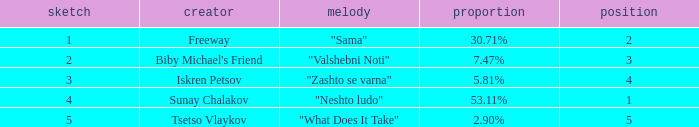Can you give me this table as a dict? {'header': ['sketch', 'creator', 'melody', 'proportion', 'position'], 'rows': [['1', 'Freeway', '"Sama"', '30.71%', '2'], ['2', "Biby Michael's Friend", '"Valshebni Noti"', '7.47%', '3'], ['3', 'Iskren Petsov', '"Zashto se varna"', '5.81%', '4'], ['4', 'Sunay Chalakov', '"Neshto ludo"', '53.11%', '1'], ['5', 'Tsetso Vlaykov', '"What Does It Take"', '2.90%', '5']]} What is the least draw when the place is higher than 4? 5.0. 